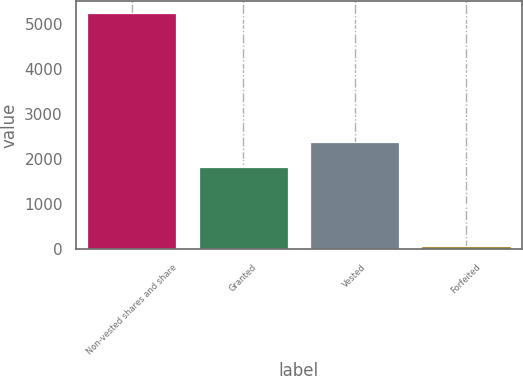Convert chart. <chart><loc_0><loc_0><loc_500><loc_500><bar_chart><fcel>Non-vested shares and share<fcel>Granted<fcel>Vested<fcel>Forfeited<nl><fcel>5242<fcel>1815<fcel>2381.5<fcel>72<nl></chart> 